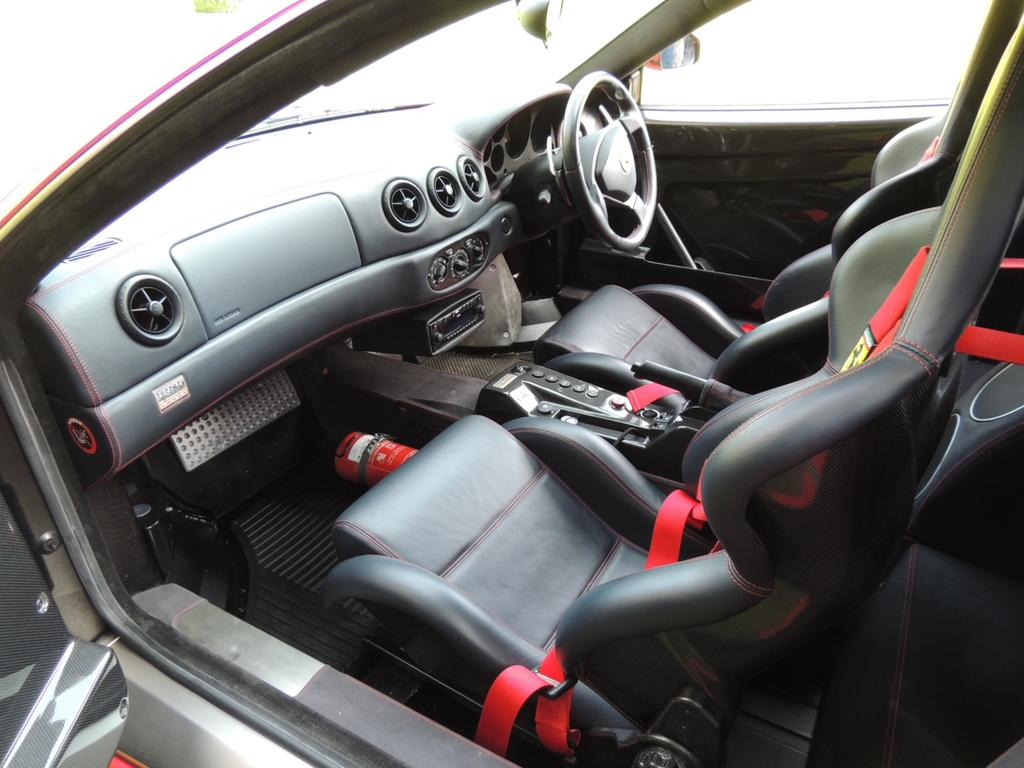What is the perspective of the image? The image is taken from inside a car. Can you describe the setting of the image? The setting of the image is not explicitly described, but it is taken from inside a car. What might be visible through the car windows? The view through the car windows would depend on the location and surroundings of the car, but it could include buildings, trees, or other vehicles. How many ladybugs can be seen crawling on the hill in the image? There is no hill or ladybugs present in the image, as it is taken from inside a car. 